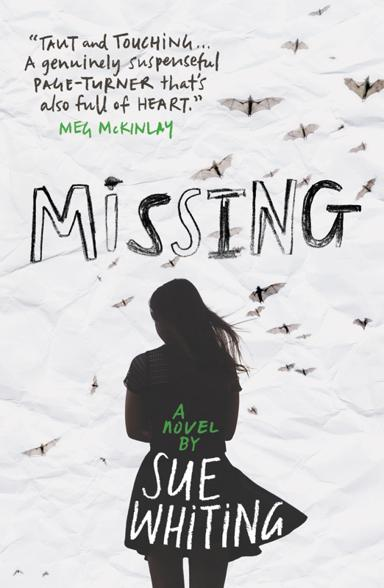What kind of praise does the novel receive in the image? The novel 'Missing' is lauded with high acclaim according to the cover image, as Meg McKinlay describes it as 'Taut and Touching,' 'genuinely suspenseful,' and a 'page-turner that's also full of heart.' These endorsements highlight the novel's capacity to engage and move its readers, suggesting an intense and emotional narrative. 